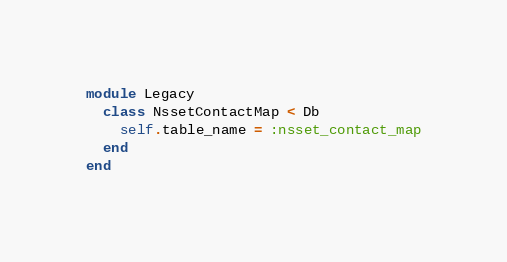Convert code to text. <code><loc_0><loc_0><loc_500><loc_500><_Ruby_>module Legacy
  class NssetContactMap < Db
    self.table_name = :nsset_contact_map
  end
end
</code> 